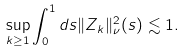Convert formula to latex. <formula><loc_0><loc_0><loc_500><loc_500>\sup _ { k \geq 1 } \int _ { 0 } ^ { 1 } d s \| Z _ { k } \| _ { \nu } ^ { 2 } ( s ) \lesssim 1 .</formula> 